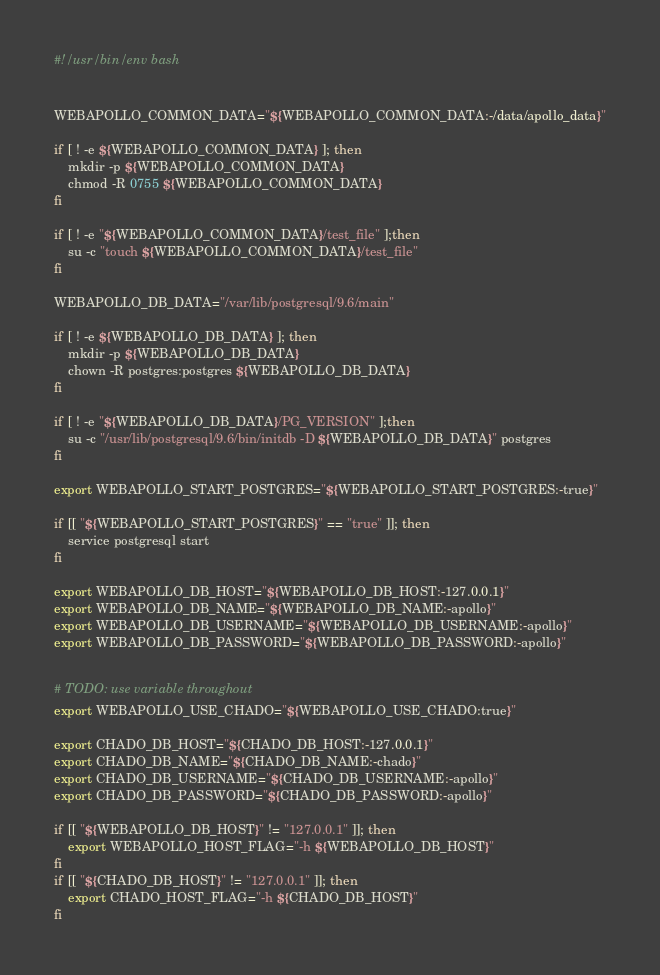<code> <loc_0><loc_0><loc_500><loc_500><_Bash_>#!/usr/bin/env bash


WEBAPOLLO_COMMON_DATA="${WEBAPOLLO_COMMON_DATA:-/data/apollo_data}"

if [ ! -e ${WEBAPOLLO_COMMON_DATA} ]; then
	mkdir -p ${WEBAPOLLO_COMMON_DATA}
	chmod -R 0755 ${WEBAPOLLO_COMMON_DATA}
fi

if [ ! -e "${WEBAPOLLO_COMMON_DATA}/test_file" ];then
	su -c "touch ${WEBAPOLLO_COMMON_DATA}/test_file"
fi

WEBAPOLLO_DB_DATA="/var/lib/postgresql/9.6/main"

if [ ! -e ${WEBAPOLLO_DB_DATA} ]; then
	mkdir -p ${WEBAPOLLO_DB_DATA}
	chown -R postgres:postgres ${WEBAPOLLO_DB_DATA}
fi

if [ ! -e "${WEBAPOLLO_DB_DATA}/PG_VERSION" ];then
	su -c "/usr/lib/postgresql/9.6/bin/initdb -D ${WEBAPOLLO_DB_DATA}" postgres
fi

export WEBAPOLLO_START_POSTGRES="${WEBAPOLLO_START_POSTGRES:-true}"

if [[ "${WEBAPOLLO_START_POSTGRES}" == "true" ]]; then
    service postgresql start
fi

export WEBAPOLLO_DB_HOST="${WEBAPOLLO_DB_HOST:-127.0.0.1}"
export WEBAPOLLO_DB_NAME="${WEBAPOLLO_DB_NAME:-apollo}"
export WEBAPOLLO_DB_USERNAME="${WEBAPOLLO_DB_USERNAME:-apollo}"
export WEBAPOLLO_DB_PASSWORD="${WEBAPOLLO_DB_PASSWORD:-apollo}"


# TODO: use variable throughout
export WEBAPOLLO_USE_CHADO="${WEBAPOLLO_USE_CHADO:true}"

export CHADO_DB_HOST="${CHADO_DB_HOST:-127.0.0.1}"
export CHADO_DB_NAME="${CHADO_DB_NAME:-chado}"
export CHADO_DB_USERNAME="${CHADO_DB_USERNAME:-apollo}"
export CHADO_DB_PASSWORD="${CHADO_DB_PASSWORD:-apollo}"

if [[ "${WEBAPOLLO_DB_HOST}" != "127.0.0.1" ]]; then
    export WEBAPOLLO_HOST_FLAG="-h ${WEBAPOLLO_DB_HOST}"
fi
if [[ "${CHADO_DB_HOST}" != "127.0.0.1" ]]; then
    export CHADO_HOST_FLAG="-h ${CHADO_DB_HOST}"
fi
</code> 